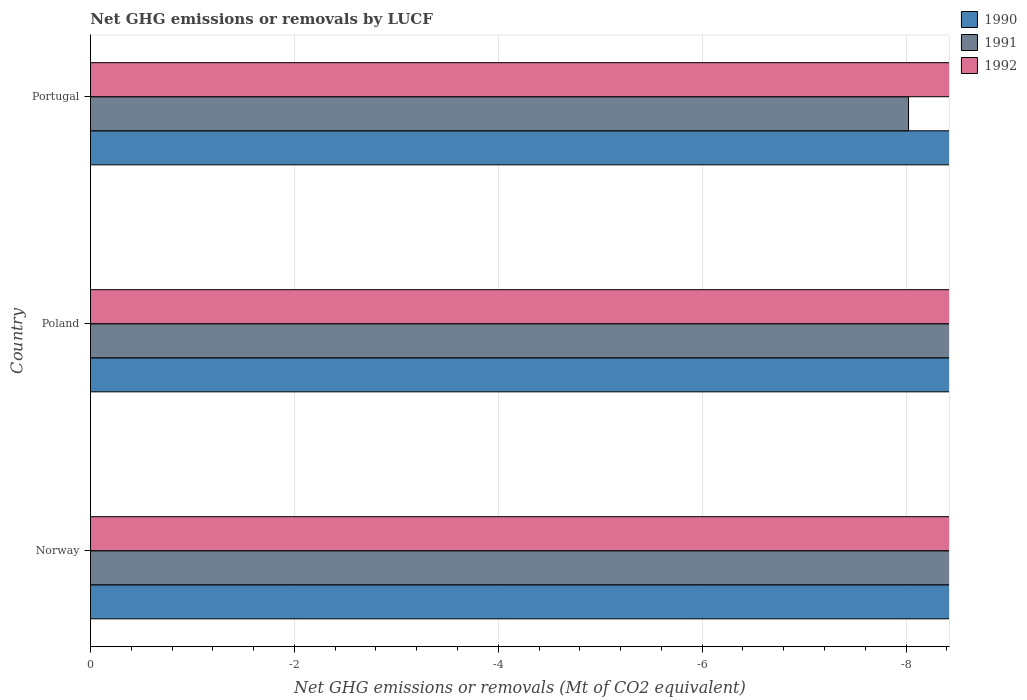How many different coloured bars are there?
Ensure brevity in your answer.  0. How many bars are there on the 1st tick from the top?
Ensure brevity in your answer.  0. How many bars are there on the 1st tick from the bottom?
Provide a succinct answer. 0. In how many cases, is the number of bars for a given country not equal to the number of legend labels?
Give a very brief answer. 3. What is the net GHG emissions or removals by LUCF in 1992 in Portugal?
Your response must be concise. 0. Across all countries, what is the minimum net GHG emissions or removals by LUCF in 1990?
Provide a short and direct response. 0. What is the difference between the net GHG emissions or removals by LUCF in 1991 in Poland and the net GHG emissions or removals by LUCF in 1990 in Portugal?
Give a very brief answer. 0. What is the average net GHG emissions or removals by LUCF in 1990 per country?
Your answer should be compact. 0. In how many countries, is the net GHG emissions or removals by LUCF in 1991 greater than -1.2 Mt?
Your answer should be very brief. 0. Is it the case that in every country, the sum of the net GHG emissions or removals by LUCF in 1991 and net GHG emissions or removals by LUCF in 1992 is greater than the net GHG emissions or removals by LUCF in 1990?
Provide a succinct answer. No. Are all the bars in the graph horizontal?
Your answer should be very brief. Yes. Are the values on the major ticks of X-axis written in scientific E-notation?
Your answer should be compact. No. Does the graph contain any zero values?
Your response must be concise. Yes. How many legend labels are there?
Provide a succinct answer. 3. How are the legend labels stacked?
Offer a very short reply. Vertical. What is the title of the graph?
Provide a short and direct response. Net GHG emissions or removals by LUCF. Does "1996" appear as one of the legend labels in the graph?
Your answer should be very brief. No. What is the label or title of the X-axis?
Give a very brief answer. Net GHG emissions or removals (Mt of CO2 equivalent). What is the Net GHG emissions or removals (Mt of CO2 equivalent) of 1991 in Norway?
Provide a succinct answer. 0. What is the Net GHG emissions or removals (Mt of CO2 equivalent) in 1990 in Portugal?
Your answer should be compact. 0. What is the Net GHG emissions or removals (Mt of CO2 equivalent) in 1991 in Portugal?
Make the answer very short. 0. What is the Net GHG emissions or removals (Mt of CO2 equivalent) of 1992 in Portugal?
Offer a terse response. 0. What is the total Net GHG emissions or removals (Mt of CO2 equivalent) in 1990 in the graph?
Offer a terse response. 0. What is the total Net GHG emissions or removals (Mt of CO2 equivalent) in 1991 in the graph?
Provide a succinct answer. 0. What is the average Net GHG emissions or removals (Mt of CO2 equivalent) in 1990 per country?
Your answer should be very brief. 0. What is the average Net GHG emissions or removals (Mt of CO2 equivalent) of 1992 per country?
Provide a short and direct response. 0. 